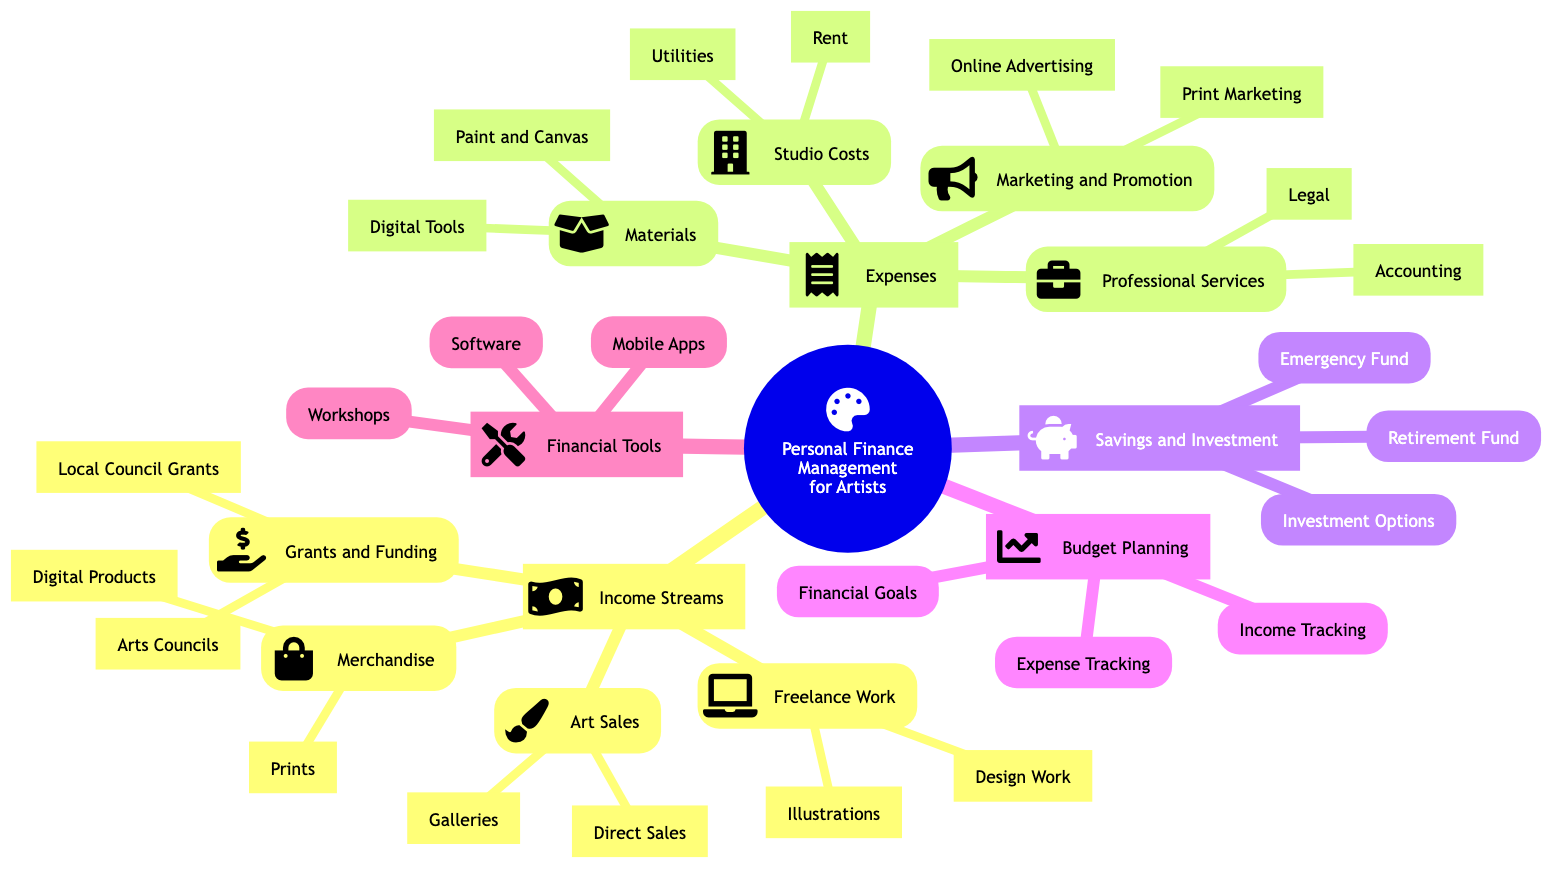What are the four main categories of personal finance management for artists? The diagram shows five main categories including Income Streams, Expenses, Savings and Investment, Budget Planning, and Financial Tools.
Answer: Income Streams, Expenses, Savings and Investment, Budget Planning, Financial Tools How many income streams are listed in the diagram? There are four income streams displayed in the diagram: Art Sales, Merchandise, Grants and Funding, and Freelance Work, making a total of four.
Answer: 4 What are the two subcategories under Art Sales? The Art Sales category includes Galleries and Direct Sales as its two subcategories, directly visible under it.
Answer: Galleries, Direct Sales Which category encompasses Online Advertising? Online Advertising is a part of the Marketing and Promotion category, as indicated in the Expenses section of the diagram.
Answer: Marketing and Promotion What type of fund is suggested for emergencies? The diagram indicates that an Emergency Fund is categorized under Savings and Investment, specifically meant for covering essential expenses during unforeseen circumstances.
Answer: Emergency Fund How many professional services are identified in the diagram? The Professional Services category contains two identified services: Legal and Accounting. Counting these gives a total of two professional services.
Answer: 2 What software tools are recommended for financial management? Under the Financial Tools section, the software recommendations mentioned are QuickBooks and FreshBooks, as listed in the diagram.
Answer: QuickBooks, FreshBooks What is the minimum recommended amount for an Emergency Fund? The diagram suggests that an Emergency Fund should cover 3-6 months of essential expenses, providing a clear guideline for its amount.
Answer: 3-6 Months of Essential Expenses What type of products are included in Merchandise? The Merchandise category includes Prints and Digital Products indicating the types of artworks that can be sold in a different format.
Answer: Prints, Digital Products 